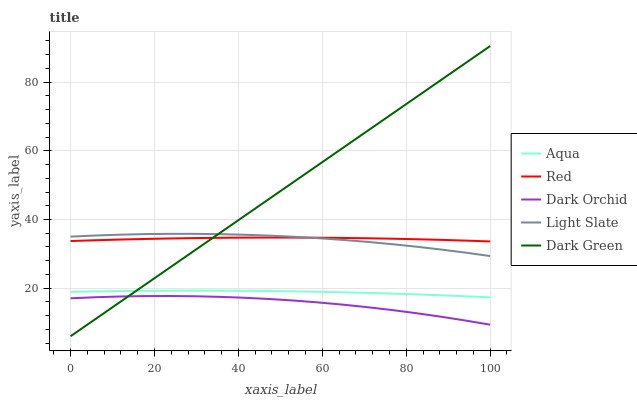Does Dark Orchid have the minimum area under the curve?
Answer yes or no. Yes. Does Dark Green have the maximum area under the curve?
Answer yes or no. Yes. Does Aqua have the minimum area under the curve?
Answer yes or no. No. Does Aqua have the maximum area under the curve?
Answer yes or no. No. Is Dark Green the smoothest?
Answer yes or no. Yes. Is Dark Orchid the roughest?
Answer yes or no. Yes. Is Aqua the smoothest?
Answer yes or no. No. Is Aqua the roughest?
Answer yes or no. No. Does Dark Green have the lowest value?
Answer yes or no. Yes. Does Aqua have the lowest value?
Answer yes or no. No. Does Dark Green have the highest value?
Answer yes or no. Yes. Does Aqua have the highest value?
Answer yes or no. No. Is Dark Orchid less than Aqua?
Answer yes or no. Yes. Is Aqua greater than Dark Orchid?
Answer yes or no. Yes. Does Dark Green intersect Red?
Answer yes or no. Yes. Is Dark Green less than Red?
Answer yes or no. No. Is Dark Green greater than Red?
Answer yes or no. No. Does Dark Orchid intersect Aqua?
Answer yes or no. No. 